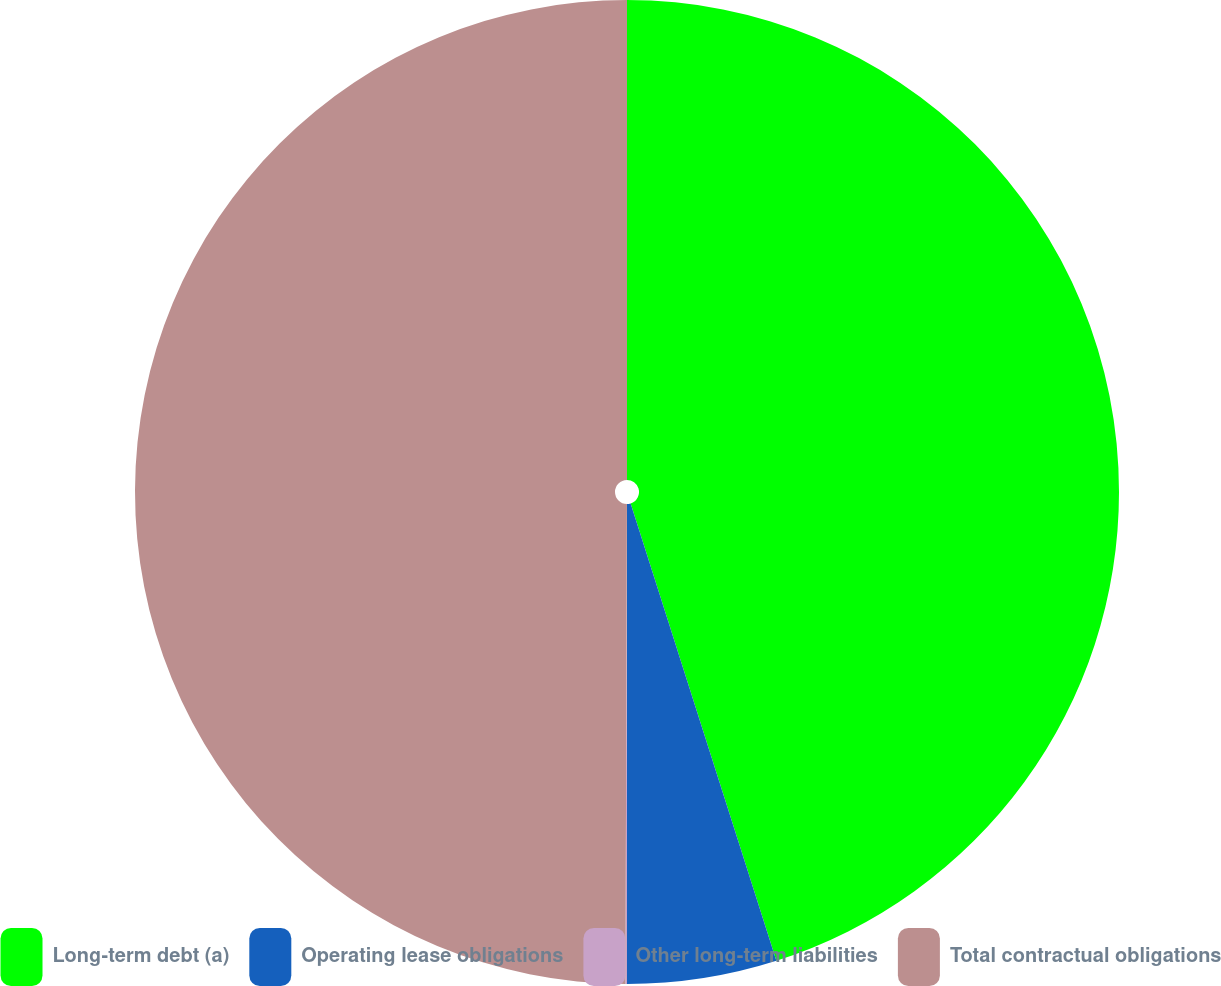Convert chart. <chart><loc_0><loc_0><loc_500><loc_500><pie_chart><fcel>Long-term debt (a)<fcel>Operating lease obligations<fcel>Other long-term liabilities<fcel>Total contractual obligations<nl><fcel>45.09%<fcel>4.91%<fcel>0.05%<fcel>49.95%<nl></chart> 